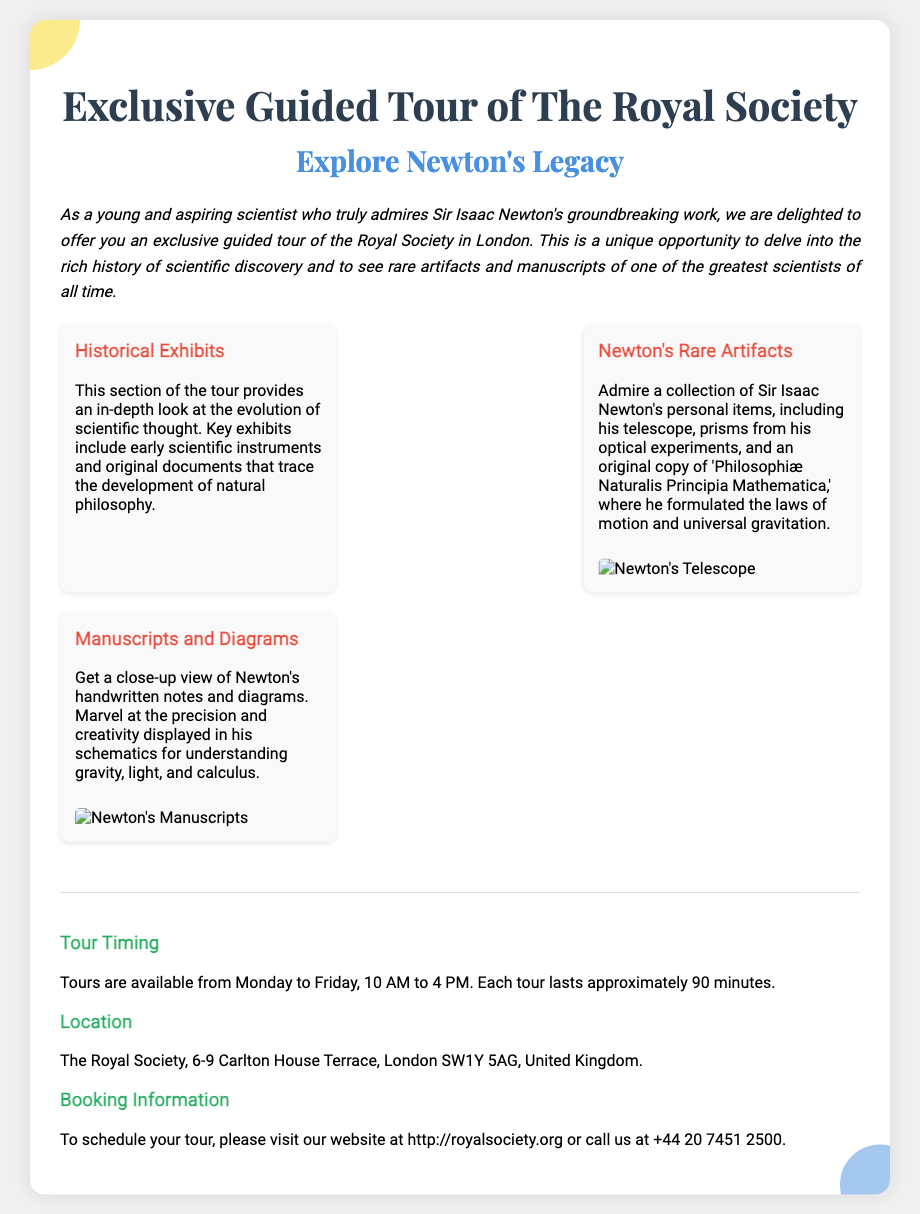What is the title of the voucher? The title of the voucher is prominently displayed at the top of the document.
Answer: Exclusive Guided Tour of The Royal Society What is the main focus of the tour? The focus of the tour is highlighted under the subtitle of the voucher.
Answer: Explore Newton's Legacy What day of the week are the tours available? The document specifies the availability of tours.
Answer: Monday to Friday What is the duration of each tour? The document states the approximate length of the tours.
Answer: 90 minutes Where is the Royal Society located? The location details are provided in the additional information section.
Answer: 6-9 Carlton House Terrace, London SW1Y 5AG, United Kingdom What item from Newton's collection is mentioned first? The order of items in Newton's rare artifacts highlights the first item listed.
Answer: Telescope How can one book the tour? The booking instructions are clearly outlined in the document.
Answer: Visit the website or call Which two types of exhibits are highlighted in the tour? The document outlines specific types of exhibits included in the tour.
Answer: Historical Exhibits, Newton's Rare Artifacts 